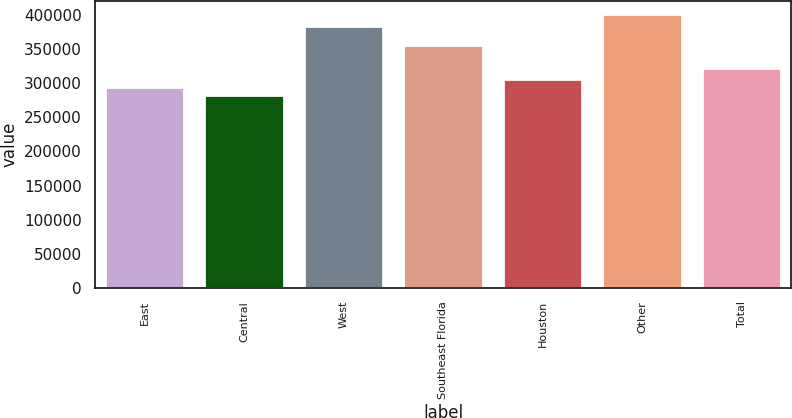<chart> <loc_0><loc_0><loc_500><loc_500><bar_chart><fcel>East<fcel>Central<fcel>West<fcel>Southeast Florida<fcel>Houston<fcel>Other<fcel>Total<nl><fcel>294800<fcel>283000<fcel>384000<fcel>356000<fcel>306600<fcel>401000<fcel>323000<nl></chart> 